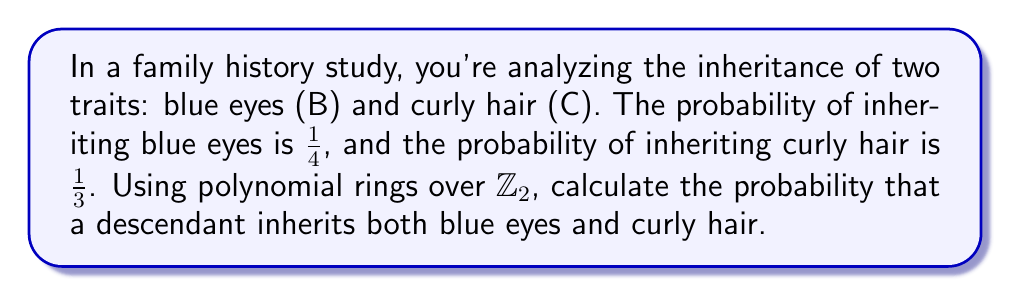Could you help me with this problem? To solve this problem using polynomial rings, we'll follow these steps:

1) First, let's define our polynomial ring. We'll use $R = \mathbb{Z}_2[x,y]$, where $x$ represents blue eyes and $y$ represents curly hair.

2) In this ring, we can represent the probability of inheriting each trait as follows:
   - Blue eyes: $B(x) = \frac{1}{4}x + \frac{3}{4}$
   - Curly hair: $C(y) = \frac{1}{3}y + \frac{2}{3}$

3) To find the probability of inheriting both traits, we need to multiply these polynomials:

   $P(x,y) = B(x) \cdot C(y) = (\frac{1}{4}x + \frac{3}{4})(\frac{1}{3}y + \frac{2}{3})$

4) Expanding this product:

   $P(x,y) = \frac{1}{12}xy + \frac{1}{6}x + \frac{1}{4}y + \frac{1}{2}$

5) In this polynomial, the coefficient of $xy$ represents the probability of inheriting both traits.

Therefore, the probability of inheriting both blue eyes and curly hair is $\frac{1}{12}$.

This method using polynomial rings is particularly useful in genealogy studies as it allows for easy computation of multiple trait inheritances and can be extended to more complex scenarios with additional traits.
Answer: $\frac{1}{12}$ 